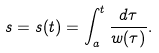<formula> <loc_0><loc_0><loc_500><loc_500>s = s ( t ) = \int _ { a } ^ { t } \frac { d \tau } { w ( \tau ) } .</formula> 